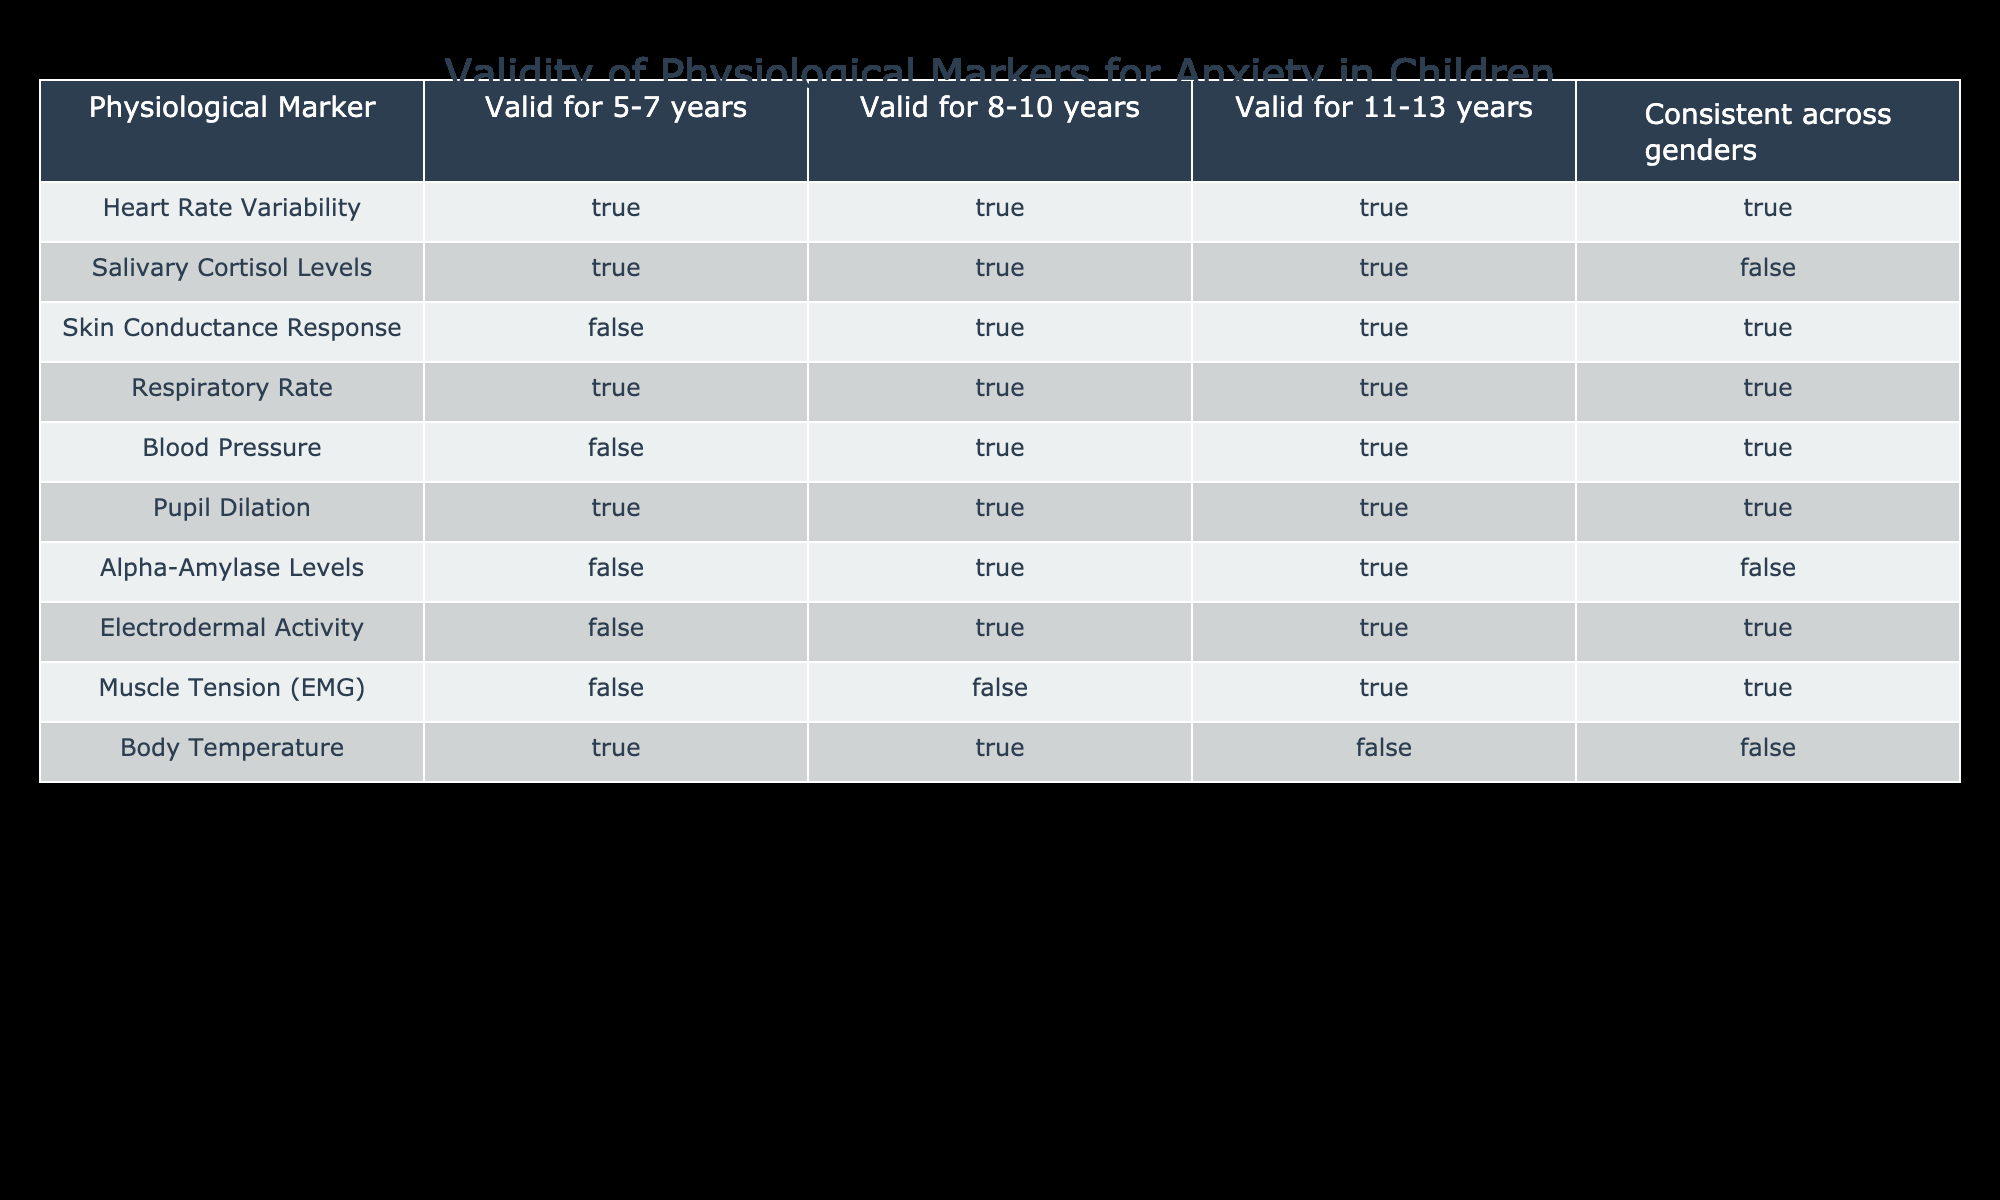What physiological marker is valid for ages 5-7? Looking at the table, the physiological markers that are marked as valid for the age range of 5-7 years include Heart Rate Variability, Salivary Cortisol Levels, Respiratory Rate, Pupil Dilation, and Body Temperature.
Answer: Heart Rate Variability, Salivary Cortisol Levels, Respiratory Rate, Pupil Dilation, Body Temperature Is Skin Conductance Response valid for 5-7 years? Referring to the table, Skin Conductance Response is marked as FALSE for the 5-7 age range, indicating that it is not a valid marker for this age group.
Answer: No How many physiological markers are valid for ages 11-13 years? Counting the rows under the column for ages 11-13 years, there are six markers confirmed as valid: Heart Rate Variability, Salivary Cortisol Levels, Skin Conductance Response, Respiratory Rate, Blood Pressure, and Pupil Dilation.
Answer: 6 Is Pupil Dilation consistent as a valid marker across genders? According to the table, Pupil Dilation is marked as TRUE for consistency across genders, indicating that it is a valid indicator for both genders in relation to anxiety.
Answer: Yes Which physiological marker has the least validity across all age groups? Examining the table, the physiological marker Muscle Tension (EMG) shows the least validity, as it is only marked as TRUE for the 11-13 age range and is marked as FALSE for the other age groups.
Answer: Muscle Tension (EMG) What is the total number of valid markers for ages 8-10 years? In the 8-10 years age column, the markers that are marked as TRUE are Salivary Cortisol Levels, Skin Conductance Response, Respiratory Rate, Blood Pressure, Pupil Dilation, and Electrodermal Activity. Counting these, we find 6 valid markers.
Answer: 6 How many markers are valid for 11-13 years but not for 8-10 years? Analyzing the two age columns, for 11-13 years, valid markers include: Heart Rate Variability, Salivary Cortisol Levels, Skin Conductance Response, Respiratory Rate, Blood Pressure, and Pupil Dilation. For 8-10 years, valid markers are: Salivary Cortisol Levels, Skin Conductance Response, Respiratory Rate, Blood Pressure, and Pupil Dilation. The difference is Heart Rate Variability, which is valid for 11-13 but not listed under 8-10 years.
Answer: 1 Are Alpha-Amylase Levels valid across genders? In the table, Alpha-Amylase Levels is marked as FALSE for consistency across genders, indicating that this marker's validity may differ between boys and girls.
Answer: No 